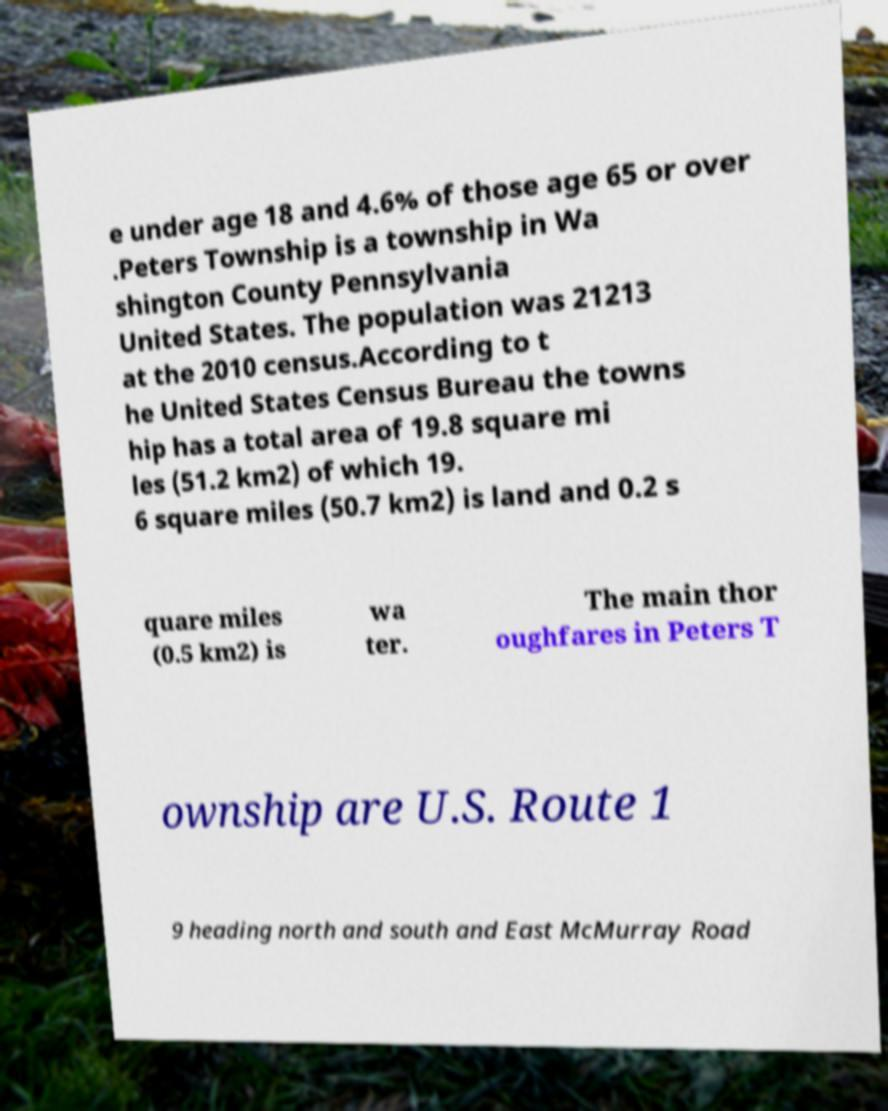What messages or text are displayed in this image? I need them in a readable, typed format. e under age 18 and 4.6% of those age 65 or over .Peters Township is a township in Wa shington County Pennsylvania United States. The population was 21213 at the 2010 census.According to t he United States Census Bureau the towns hip has a total area of 19.8 square mi les (51.2 km2) of which 19. 6 square miles (50.7 km2) is land and 0.2 s quare miles (0.5 km2) is wa ter. The main thor oughfares in Peters T ownship are U.S. Route 1 9 heading north and south and East McMurray Road 